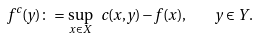<formula> <loc_0><loc_0><loc_500><loc_500>f ^ { c } ( y ) \colon = \sup _ { x \in X } \ c ( x , y ) - f ( x ) , \quad y \in Y .</formula> 